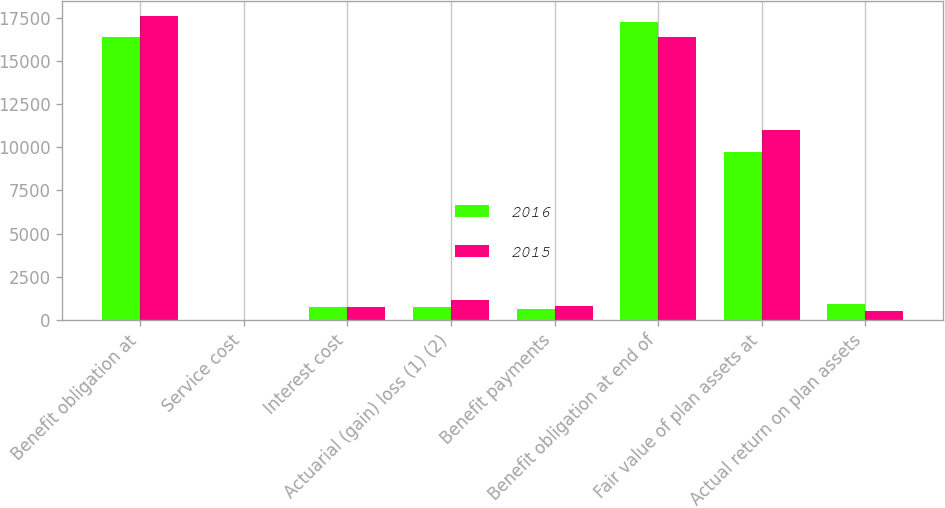<chart> <loc_0><loc_0><loc_500><loc_500><stacked_bar_chart><ecel><fcel>Benefit obligation at<fcel>Service cost<fcel>Interest cost<fcel>Actuarial (gain) loss (1) (2)<fcel>Benefit payments<fcel>Benefit obligation at end of<fcel>Fair value of plan assets at<fcel>Actual return on plan assets<nl><fcel>2016<fcel>16395<fcel>2<fcel>749<fcel>729<fcel>635<fcel>17238<fcel>9707<fcel>915<nl><fcel>2015<fcel>17594<fcel>2<fcel>737<fcel>1159<fcel>776<fcel>16395<fcel>10986<fcel>506<nl></chart> 